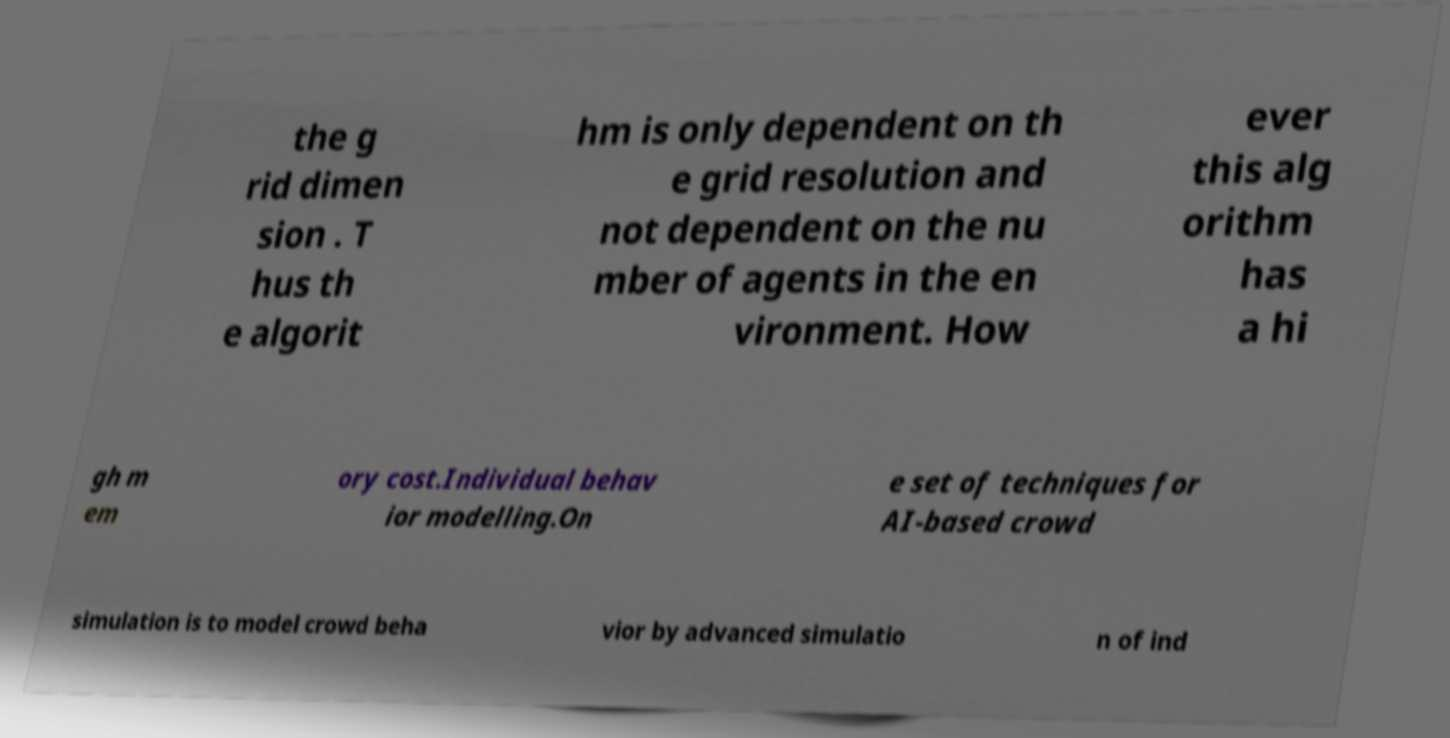Please identify and transcribe the text found in this image. the g rid dimen sion . T hus th e algorit hm is only dependent on th e grid resolution and not dependent on the nu mber of agents in the en vironment. How ever this alg orithm has a hi gh m em ory cost.Individual behav ior modelling.On e set of techniques for AI-based crowd simulation is to model crowd beha vior by advanced simulatio n of ind 